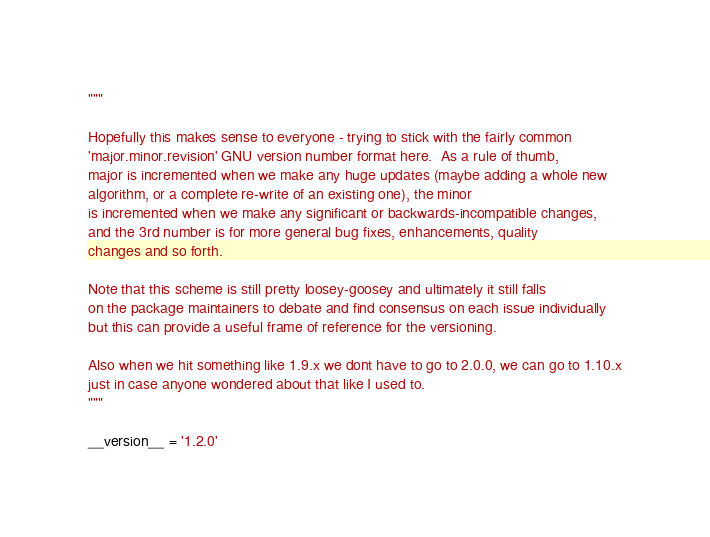Convert code to text. <code><loc_0><loc_0><loc_500><loc_500><_Python_>
"""

Hopefully this makes sense to everyone - trying to stick with the fairly common
'major.minor.revision' GNU version number format here.  As a rule of thumb,
major is incremented when we make any huge updates (maybe adding a whole new
algorithm, or a complete re-write of an existing one), the minor
is incremented when we make any significant or backwards-incompatible changes,
and the 3rd number is for more general bug fixes, enhancements, quality
changes and so forth.

Note that this scheme is still pretty loosey-goosey and ultimately it still falls
on the package maintainers to debate and find consensus on each issue individually
but this can provide a useful frame of reference for the versioning.

Also when we hit something like 1.9.x we dont have to go to 2.0.0, we can go to 1.10.x
just in case anyone wondered about that like I used to.
"""

__version__ = '1.2.0'
</code> 